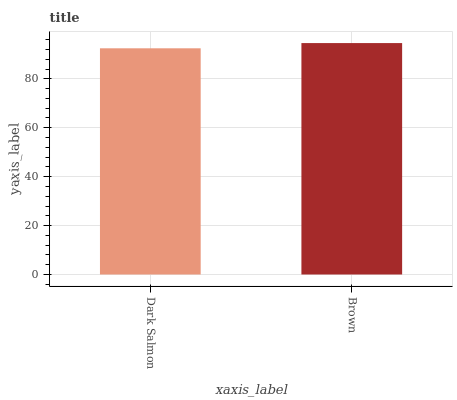Is Dark Salmon the minimum?
Answer yes or no. Yes. Is Brown the maximum?
Answer yes or no. Yes. Is Brown the minimum?
Answer yes or no. No. Is Brown greater than Dark Salmon?
Answer yes or no. Yes. Is Dark Salmon less than Brown?
Answer yes or no. Yes. Is Dark Salmon greater than Brown?
Answer yes or no. No. Is Brown less than Dark Salmon?
Answer yes or no. No. Is Brown the high median?
Answer yes or no. Yes. Is Dark Salmon the low median?
Answer yes or no. Yes. Is Dark Salmon the high median?
Answer yes or no. No. Is Brown the low median?
Answer yes or no. No. 